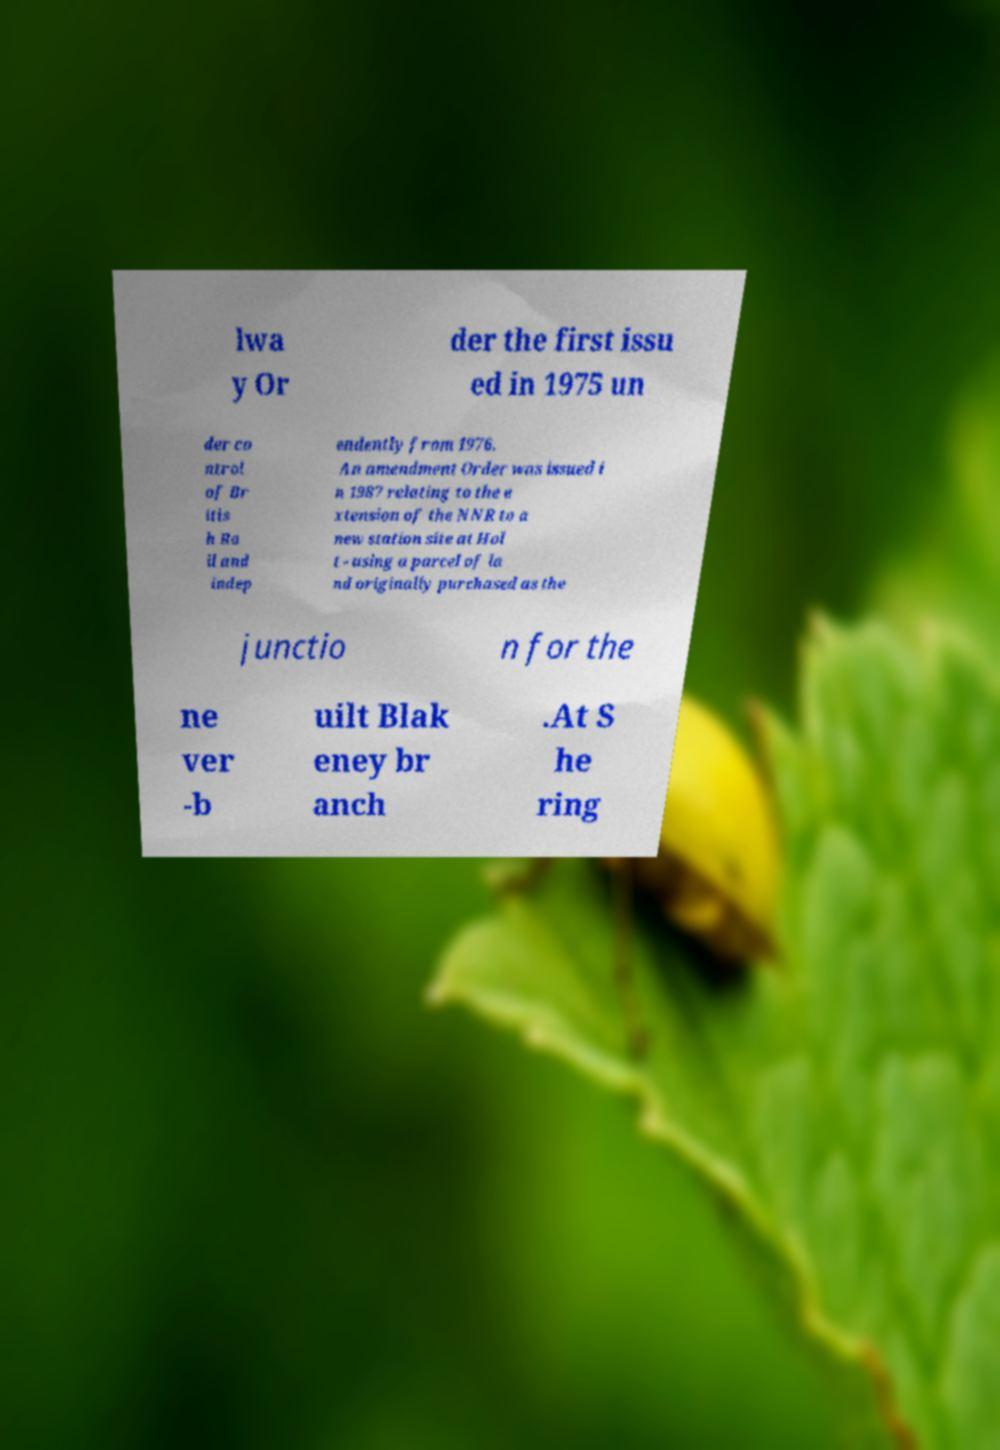Can you accurately transcribe the text from the provided image for me? lwa y Or der the first issu ed in 1975 un der co ntrol of Br itis h Ra il and indep endently from 1976. An amendment Order was issued i n 1987 relating to the e xtension of the NNR to a new station site at Hol t - using a parcel of la nd originally purchased as the junctio n for the ne ver -b uilt Blak eney br anch .At S he ring 